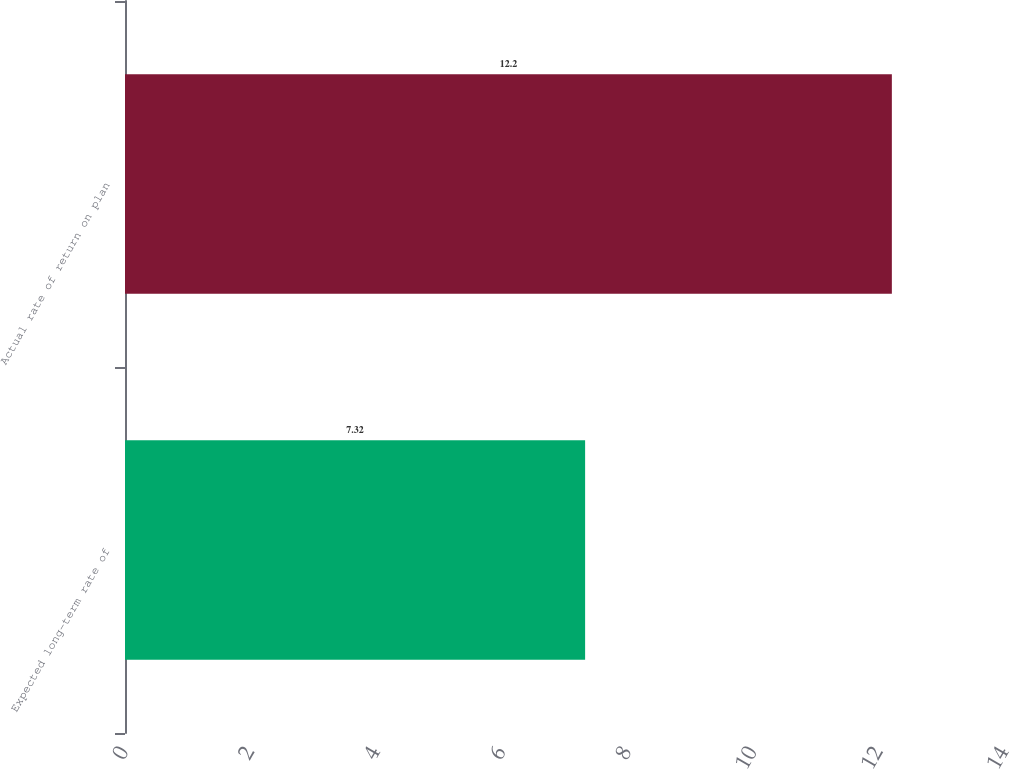Convert chart to OTSL. <chart><loc_0><loc_0><loc_500><loc_500><bar_chart><fcel>Expected long-term rate of<fcel>Actual rate of return on plan<nl><fcel>7.32<fcel>12.2<nl></chart> 